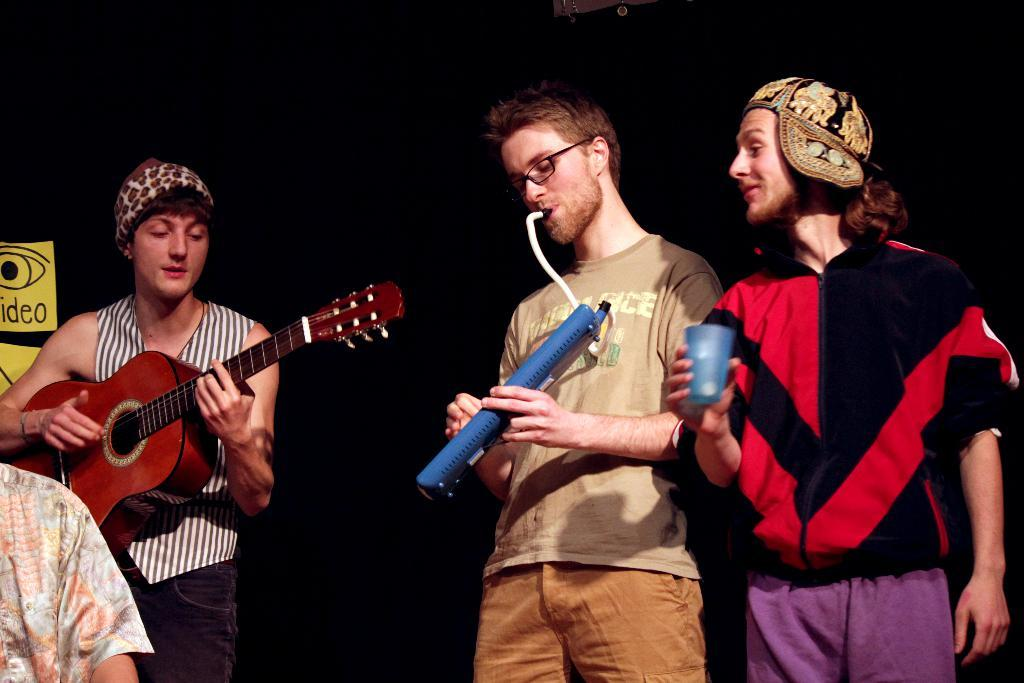How many people are playing musical instruments in the image? There are two men in the image, and they are playing musical instruments. What is the person on the right side of the image holding? The person on the right is holding a glass in his hand. What type of knowledge can be seen in the clouds in the image? There are no clouds present in the image, and therefore no knowledge can be seen in them. 